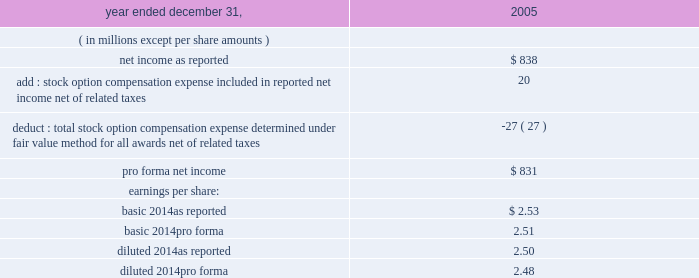The table illustrates the pro forma effect on net income and earnings per share as if all outstanding and unvested stock options in 2005 were accounted for using estimated fair value .
2005year ended december 31 .
Basic earnings per share is calculated by dividing net income available to common shareholders by the weighted-average number of common shares outstanding for the period , which excludes unvested shares of restricted stock .
Diluted earnings per share is calculated by dividing net income available to common shareholders by the weighted-average number of common shares outstanding for the period and the shares representing the dilutive effect of stock options and awards and other equity-related financial instruments .
The effect of stock options and restricted stock outstanding is excluded from the calculation of diluted earnings per share in periods in which their effect would be antidilutive .
Special purpose entities : we are involved with various legal forms of special purpose entities , or spes , in the normal course of our business .
We use trusts to structure and sell certificated interests in pools of tax-exempt investment-grade assets principally to our mutual fund customers .
These trusts are recorded in our consolidated financial statements .
We transfer assets to these trusts , which are legally isolated from us , from our investment securities portfolio at adjusted book value .
The trusts finance the acquisition of these assets by selling certificated interests issued by the trusts to third-party investors .
The investment securities of the trusts are carried in investments securities available for sale at fair value .
The certificated interests are carried in other short-term borrowings at the amount owed to the third-party investors .
The interest revenue and interest expense generated by the investments and certificated interests , respectively , are recorded in net interest revenue when earned or incurred. .
What is the diluted number of outstanding shares based on the eps , ( in millions ) ? 
Computations: (838 / 2.50)
Answer: 335.2. 